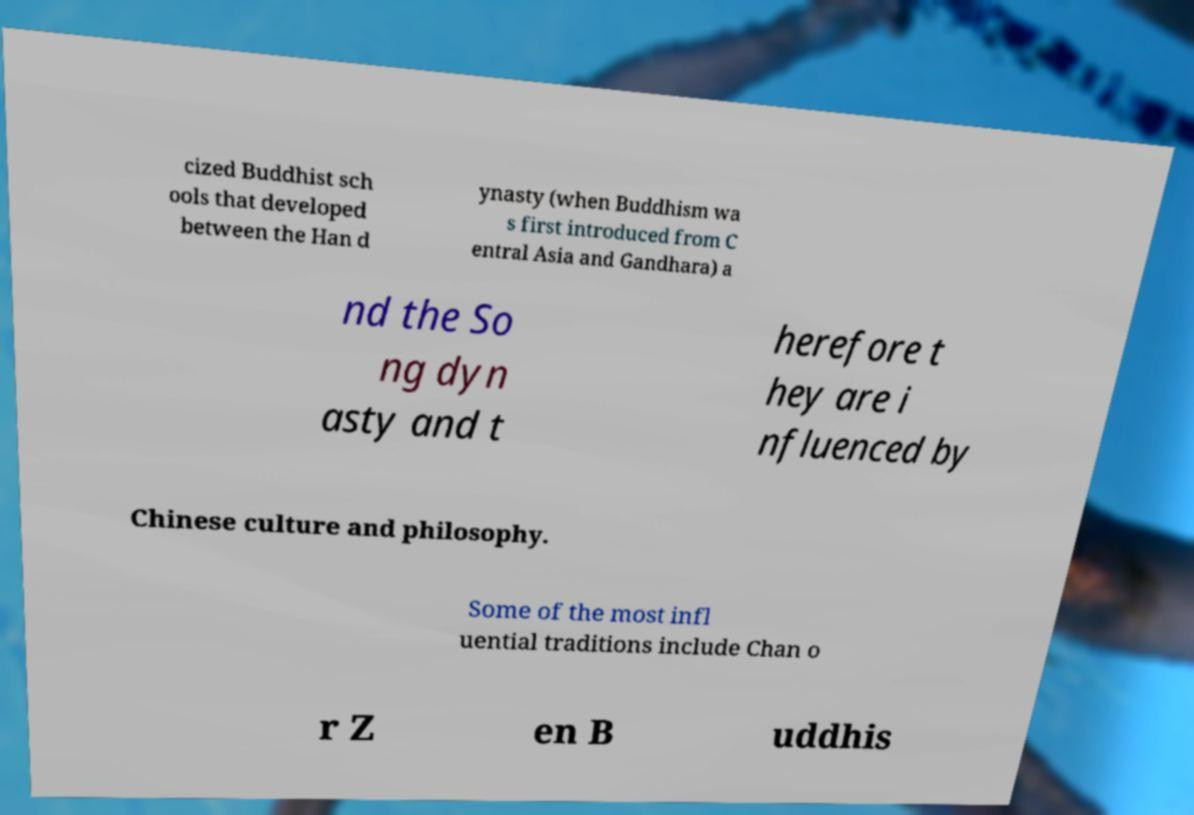Can you read and provide the text displayed in the image?This photo seems to have some interesting text. Can you extract and type it out for me? cized Buddhist sch ools that developed between the Han d ynasty (when Buddhism wa s first introduced from C entral Asia and Gandhara) a nd the So ng dyn asty and t herefore t hey are i nfluenced by Chinese culture and philosophy. Some of the most infl uential traditions include Chan o r Z en B uddhis 